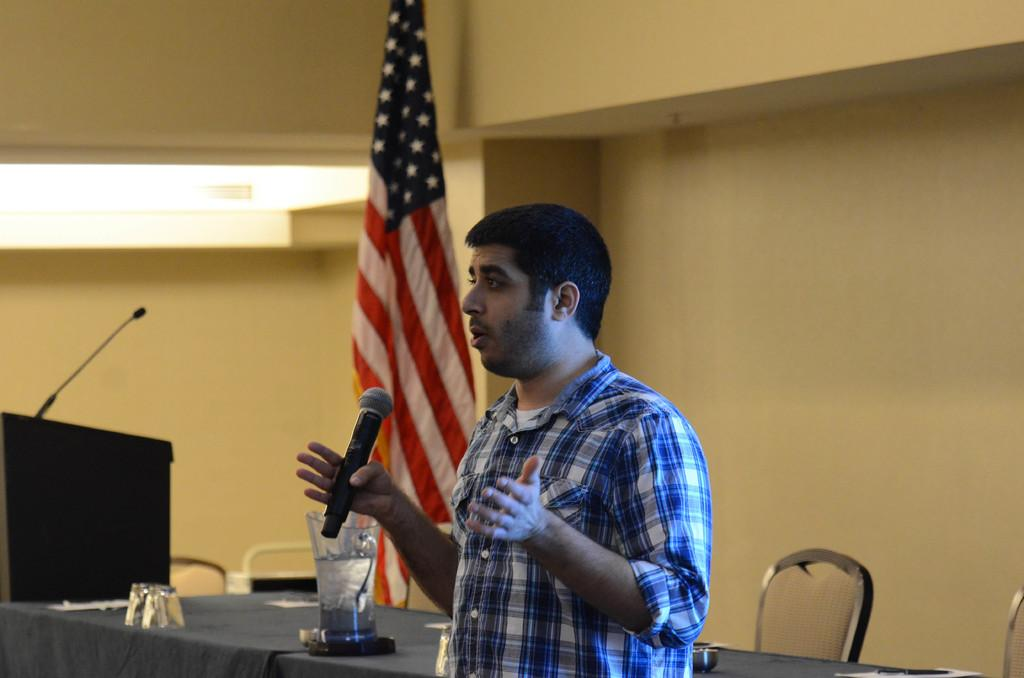What is the man in the image doing? The man is standing in the image and holding a microphone. What might the man be using the microphone for? The man might be using the microphone for speaking or singing. Can you describe the man's hand position in the image? The man has his hand behind him in the image. What other objects or structures are present in the image? There is a table and a flag in the image. What type of songs can be heard coming from the bag in the image? There is no bag present in the image, so it's not possible to determine what, if any, songs might be heard. 